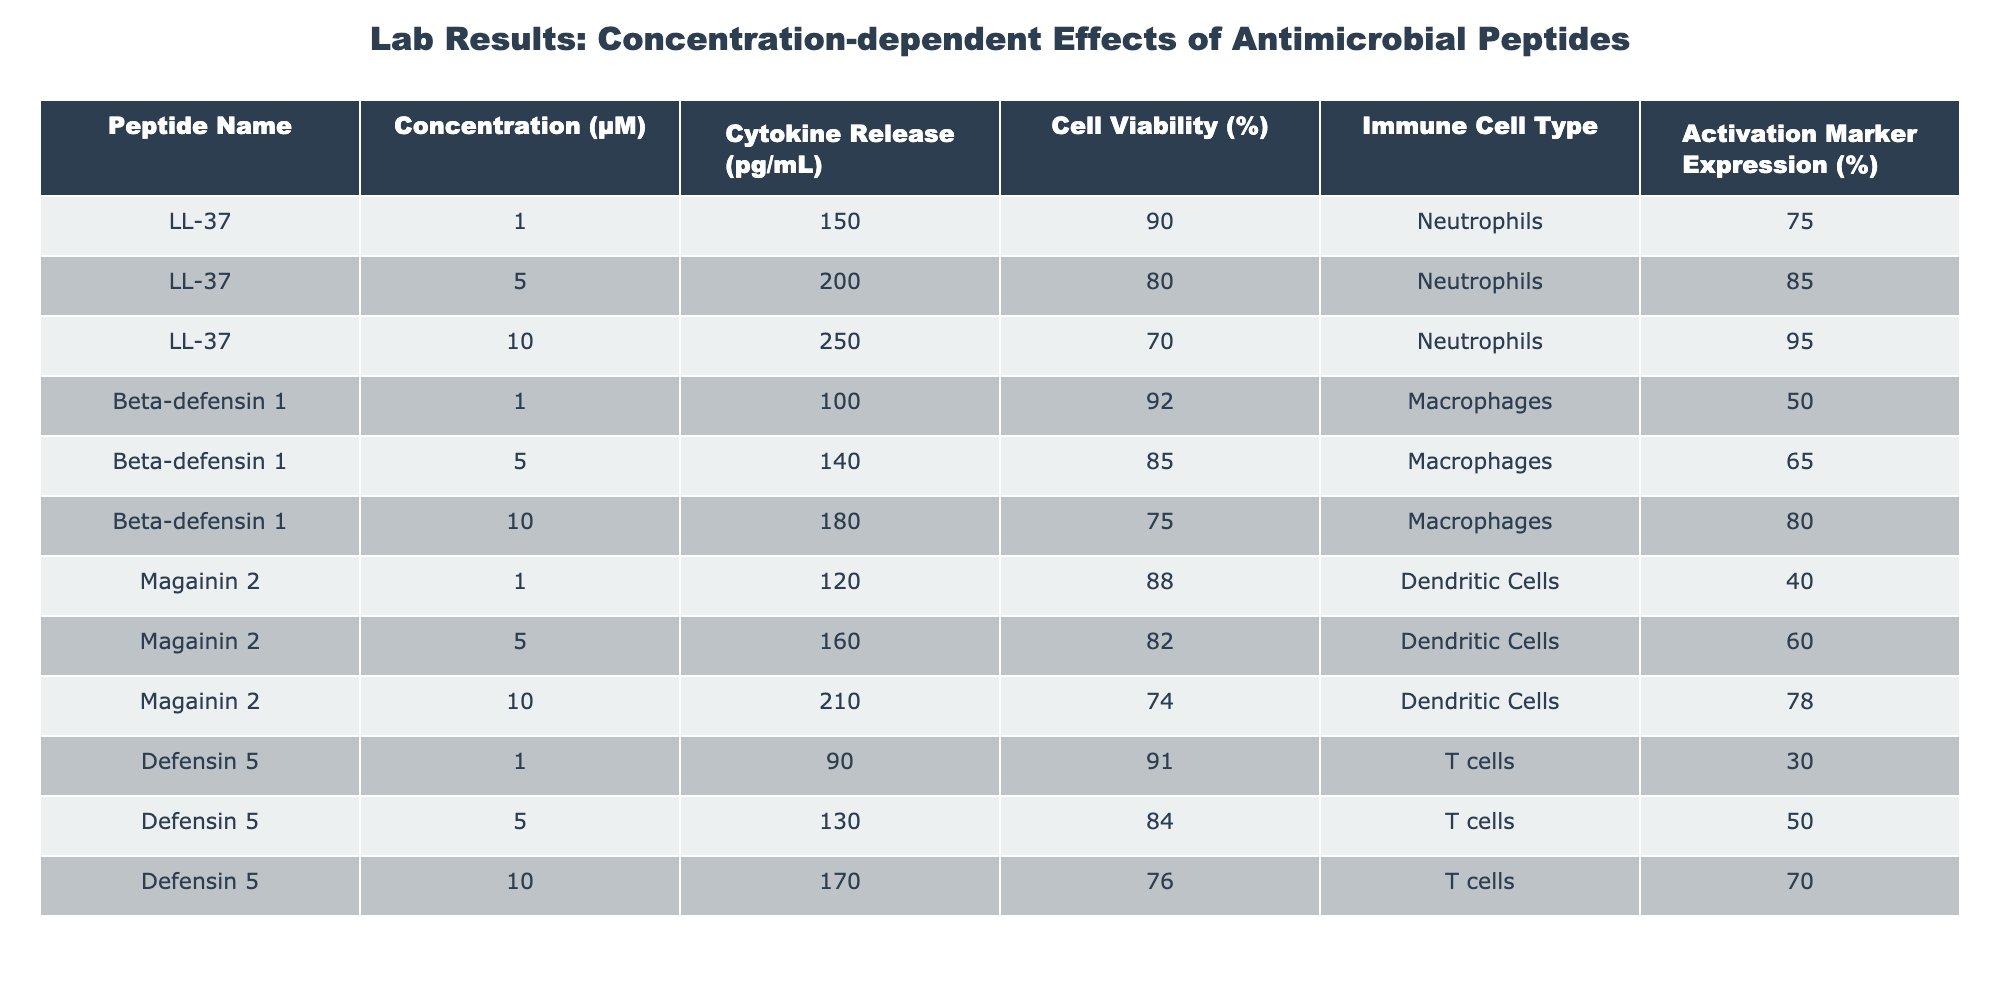What is the cytokine release at a concentration of 10 µM for LL-37? According to the table, under the "Cytokine Release (pg/mL)" column, at a concentration of 10 µM for LL-37, the value is 250 pg/mL.
Answer: 250 pg/mL What percentage of cell viability is recorded for Beta-defensin 1 at 5 µM? For Beta-defensin 1 at 5 µM, the "Cell Viability (%)" column shows a value of 85%.
Answer: 85% Is the expression of the activation marker CD25 for Defensin 5 at 1 µM greater than 30%? The activation marker expression for Defensin 5 at 1 µM is given as CD25: 30%. Since 30% is not greater than 30%, the answer is no.
Answer: No What is the average cytokine release for Magainin 2 across all concentrations? The cytokine releases for Magainin 2 are 120 (1 µM) + 160 (5 µM) + 210 (10 µM) = 490 pg/mL. There are three values, so the average is 490/3 = approximately 163.33 pg/mL.
Answer: 163.33 pg/mL Which immune cell type showed the highest activation marker expression at 10 µM? By checking the "Activation Marker Expression (%)" for all immune cells at 10 µM, LL-37 shows an expression of 95% for Neutrophils, Beta-defensin 1 shows 80% for Macrophages, Magainin 2 shows 78% for Dendritic Cells, and Defensin 5 shows 70% for T cells. Thus, LL-37 has the highest expression at 95%.
Answer: Neutrophils How many µM shows increased cytokine release for Beta-defensin 1, based on the given concentrations? Looking at the cytokine release values: 100 pg/mL (1 µM), 140 pg/mL (5 µM), and 180 pg/mL (10 µM), we can see that all concentrations show increased values.
Answer: All concentrations (1, 5, and 10 µM) show increased release Is cell viability for Magainin 2 at 5 µM above 80%? The table indicates the cell viability for Magainin 2 at 5 µM is 82%, which is above 80%.
Answer: Yes What is the percentage increase in activation marker expression for CD80 of Beta-defensin 1 from 1 to 10 µM? The CD80 expressions are 50% (1 µM) and 80% (10 µM). The increase is 80% - 50% = 30%. Therefore, the percentage increase is (30/50) * 100 = 60%.
Answer: 60% What is the concentration at which T cells have a cell viability of 76%? The only concentration listed for T cells with cell viability of 76% is at 10 µM.
Answer: 10 µM 